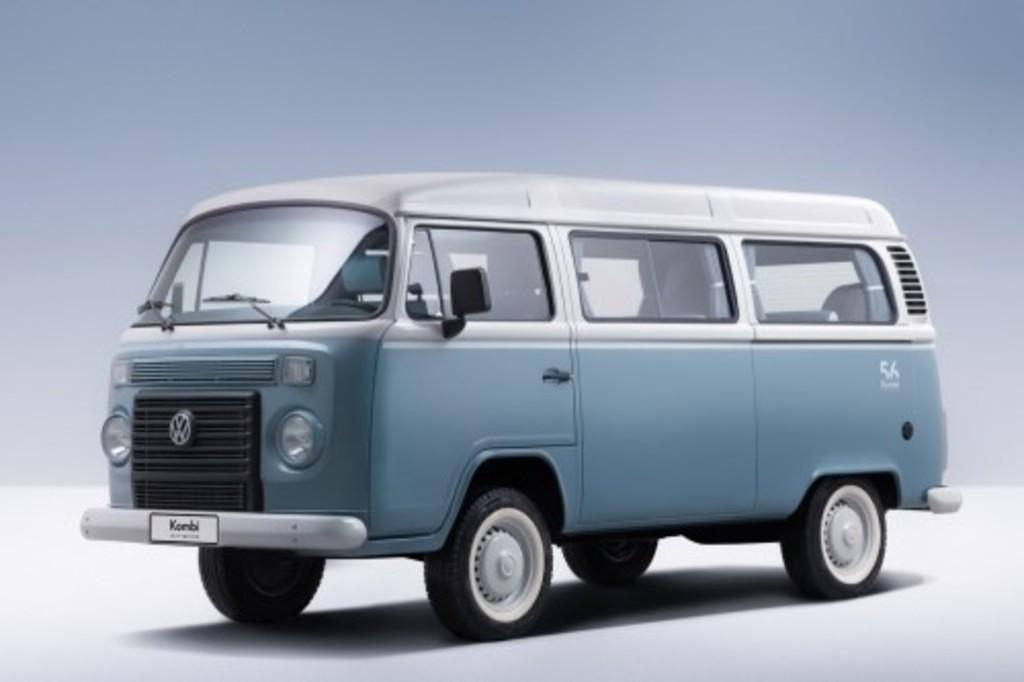What is the main subject of the image? There is a vehicle in the image. What can be seen in the background of the image? The background of the image is white. What type of shoes is the person wearing in the image? There is no person present in the image, so it is not possible to determine what type of shoes they might be wearing. 